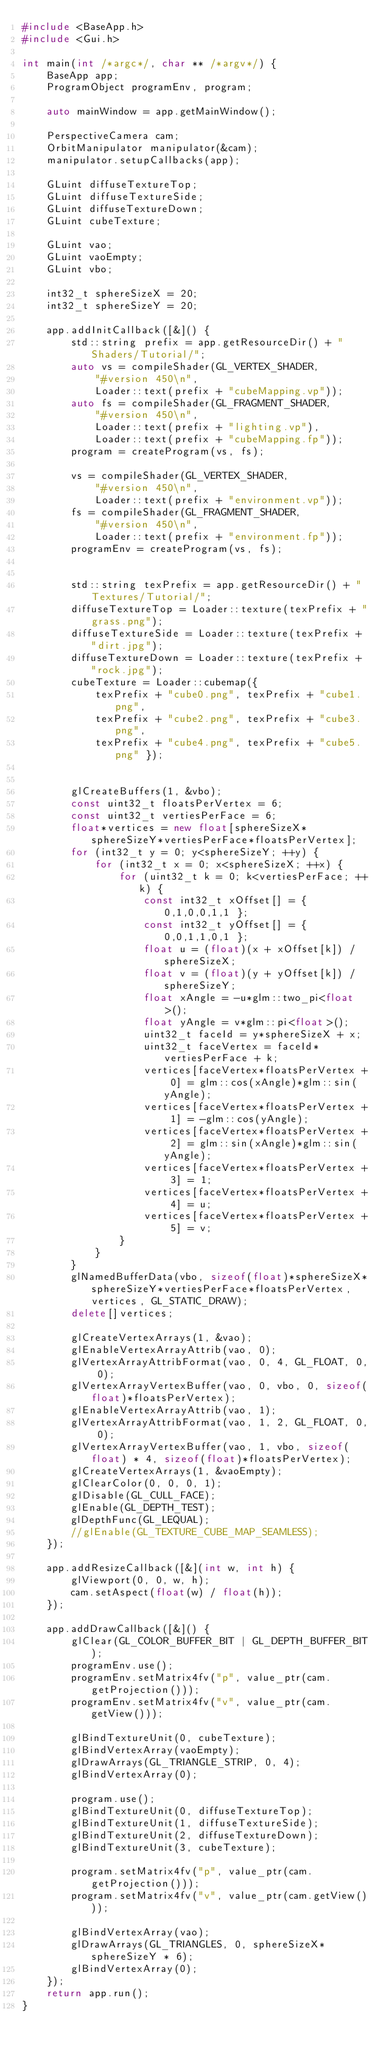<code> <loc_0><loc_0><loc_500><loc_500><_C++_>#include <BaseApp.h>
#include <Gui.h>

int main(int /*argc*/, char ** /*argv*/) {
	BaseApp app;
	ProgramObject programEnv, program;

	auto mainWindow = app.getMainWindow();

	PerspectiveCamera cam;
	OrbitManipulator manipulator(&cam);
	manipulator.setupCallbacks(app);
	
	GLuint diffuseTextureTop;
	GLuint diffuseTextureSide;
	GLuint diffuseTextureDown;
	GLuint cubeTexture;

	GLuint vao;
	GLuint vaoEmpty;
	GLuint vbo;

	int32_t sphereSizeX = 20;
	int32_t sphereSizeY = 20;

	app.addInitCallback([&]() {
		std::string prefix = app.getResourceDir() + "Shaders/Tutorial/";
		auto vs = compileShader(GL_VERTEX_SHADER,
			"#version 450\n",
			Loader::text(prefix + "cubeMapping.vp"));
		auto fs = compileShader(GL_FRAGMENT_SHADER,
			"#version 450\n",
			Loader::text(prefix + "lighting.vp"),
			Loader::text(prefix + "cubeMapping.fp"));
		program = createProgram(vs, fs);

		vs = compileShader(GL_VERTEX_SHADER,
			"#version 450\n",
			Loader::text(prefix + "environment.vp"));
		fs = compileShader(GL_FRAGMENT_SHADER,
			"#version 450\n",
			Loader::text(prefix + "environment.fp"));
		programEnv = createProgram(vs, fs);


		std::string texPrefix = app.getResourceDir() + "Textures/Tutorial/";
		diffuseTextureTop = Loader::texture(texPrefix + "grass.png");
		diffuseTextureSide = Loader::texture(texPrefix + "dirt.jpg");
		diffuseTextureDown = Loader::texture(texPrefix + "rock.jpg");
		cubeTexture = Loader::cubemap({ 
			texPrefix + "cube0.png", texPrefix + "cube1.png",
			texPrefix + "cube2.png", texPrefix + "cube3.png",
			texPrefix + "cube4.png", texPrefix + "cube5.png" });


		glCreateBuffers(1, &vbo);
		const uint32_t floatsPerVertex = 6;
		const uint32_t vertiesPerFace = 6;
		float*vertices = new float[sphereSizeX*sphereSizeY*vertiesPerFace*floatsPerVertex];
		for (int32_t y = 0; y<sphereSizeY; ++y) {
			for (int32_t x = 0; x<sphereSizeX; ++x) {
				for (uint32_t k = 0; k<vertiesPerFace; ++k) {
					const int32_t xOffset[] = { 0,1,0,0,1,1 };
					const int32_t yOffset[] = { 0,0,1,1,0,1 };
					float u = (float)(x + xOffset[k]) / sphereSizeX;
					float v = (float)(y + yOffset[k]) / sphereSizeY;
					float xAngle = -u*glm::two_pi<float>();
					float yAngle = v*glm::pi<float>();
					uint32_t faceId = y*sphereSizeX + x;
					uint32_t faceVertex = faceId*vertiesPerFace + k;
					vertices[faceVertex*floatsPerVertex + 0] = glm::cos(xAngle)*glm::sin(yAngle);
					vertices[faceVertex*floatsPerVertex + 1] = -glm::cos(yAngle);
					vertices[faceVertex*floatsPerVertex + 2] = glm::sin(xAngle)*glm::sin(yAngle);
					vertices[faceVertex*floatsPerVertex + 3] = 1;
					vertices[faceVertex*floatsPerVertex + 4] = u;
					vertices[faceVertex*floatsPerVertex + 5] = v;
				}
			}
		}
		glNamedBufferData(vbo, sizeof(float)*sphereSizeX*sphereSizeY*vertiesPerFace*floatsPerVertex, vertices, GL_STATIC_DRAW);
		delete[]vertices;

		glCreateVertexArrays(1, &vao);
		glEnableVertexArrayAttrib(vao, 0); 
		glVertexArrayAttribFormat(vao, 0, 4, GL_FLOAT, 0, 0); 
		glVertexArrayVertexBuffer(vao, 0, vbo, 0, sizeof(float)*floatsPerVertex);
		glEnableVertexArrayAttrib(vao, 1);
		glVertexArrayAttribFormat(vao, 1, 2, GL_FLOAT, 0, 0);
		glVertexArrayVertexBuffer(vao, 1, vbo, sizeof(float) * 4, sizeof(float)*floatsPerVertex);
		glCreateVertexArrays(1, &vaoEmpty);
		glClearColor(0, 0, 0, 1);
		glDisable(GL_CULL_FACE);
		glEnable(GL_DEPTH_TEST);
		glDepthFunc(GL_LEQUAL);
		//glEnable(GL_TEXTURE_CUBE_MAP_SEAMLESS);
	});

	app.addResizeCallback([&](int w, int h) {
		glViewport(0, 0, w, h);
		cam.setAspect(float(w) / float(h));
	});

	app.addDrawCallback([&]() {
		glClear(GL_COLOR_BUFFER_BIT | GL_DEPTH_BUFFER_BIT);
		programEnv.use();
		programEnv.setMatrix4fv("p", value_ptr(cam.getProjection()));
		programEnv.setMatrix4fv("v", value_ptr(cam.getView()));

		glBindTextureUnit(0, cubeTexture);
		glBindVertexArray(vaoEmpty);
		glDrawArrays(GL_TRIANGLE_STRIP, 0, 4);
		glBindVertexArray(0);

		program.use();
		glBindTextureUnit(0, diffuseTextureTop);
		glBindTextureUnit(1, diffuseTextureSide);
		glBindTextureUnit(2, diffuseTextureDown);
		glBindTextureUnit(3, cubeTexture);

		program.setMatrix4fv("p", value_ptr(cam.getProjection()));
		program.setMatrix4fv("v", value_ptr(cam.getView()));

		glBindVertexArray(vao);
		glDrawArrays(GL_TRIANGLES, 0, sphereSizeX*sphereSizeY * 6);
		glBindVertexArray(0);
	});
	return app.run();
}</code> 